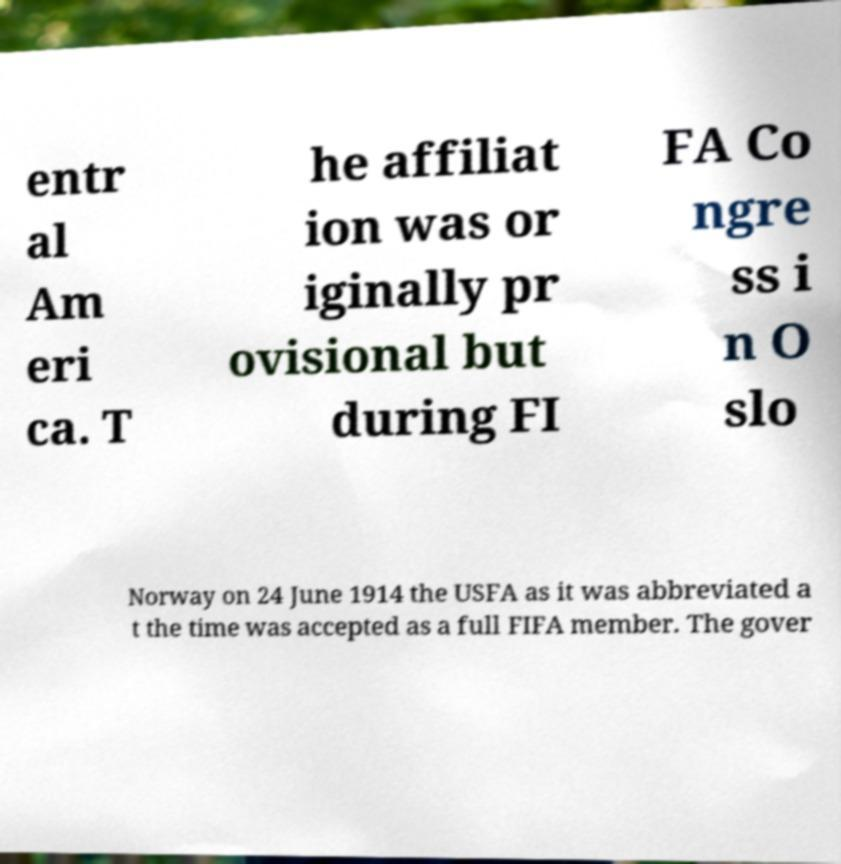For documentation purposes, I need the text within this image transcribed. Could you provide that? entr al Am eri ca. T he affiliat ion was or iginally pr ovisional but during FI FA Co ngre ss i n O slo Norway on 24 June 1914 the USFA as it was abbreviated a t the time was accepted as a full FIFA member. The gover 